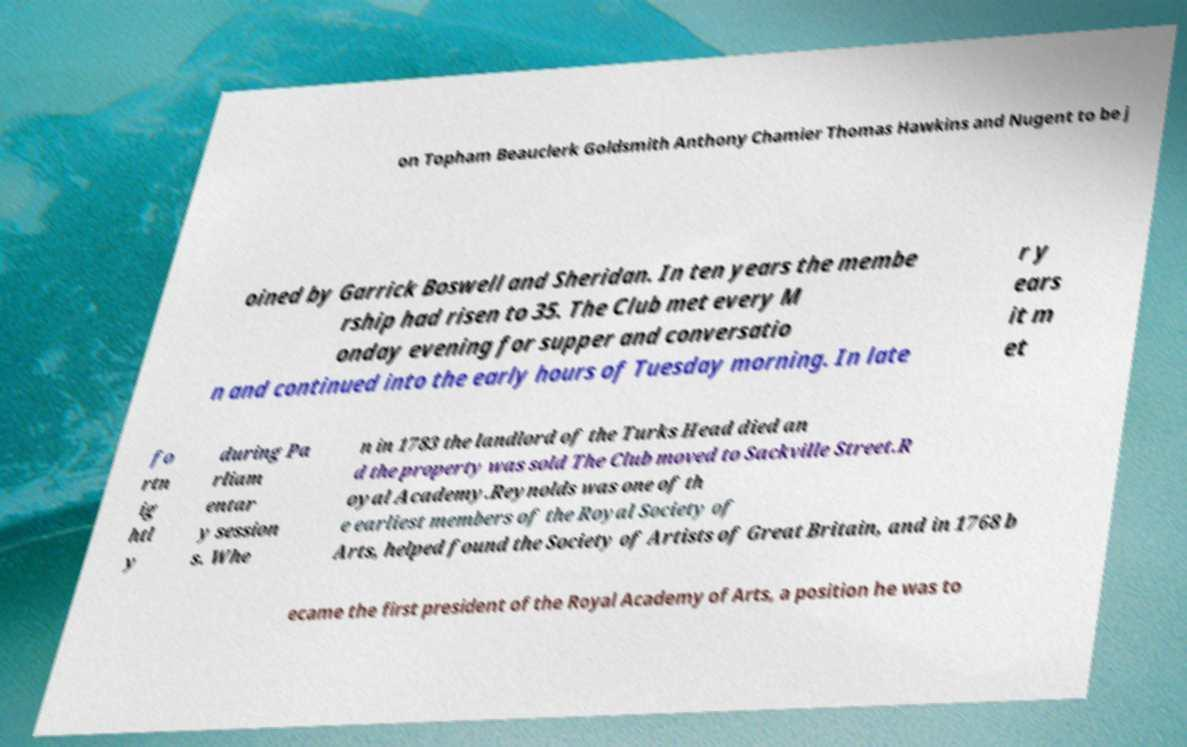Can you read and provide the text displayed in the image?This photo seems to have some interesting text. Can you extract and type it out for me? on Topham Beauclerk Goldsmith Anthony Chamier Thomas Hawkins and Nugent to be j oined by Garrick Boswell and Sheridan. In ten years the membe rship had risen to 35. The Club met every M onday evening for supper and conversatio n and continued into the early hours of Tuesday morning. In late r y ears it m et fo rtn ig htl y during Pa rliam entar y session s. Whe n in 1783 the landlord of the Turks Head died an d the property was sold The Club moved to Sackville Street.R oyal Academy.Reynolds was one of th e earliest members of the Royal Society of Arts, helped found the Society of Artists of Great Britain, and in 1768 b ecame the first president of the Royal Academy of Arts, a position he was to 